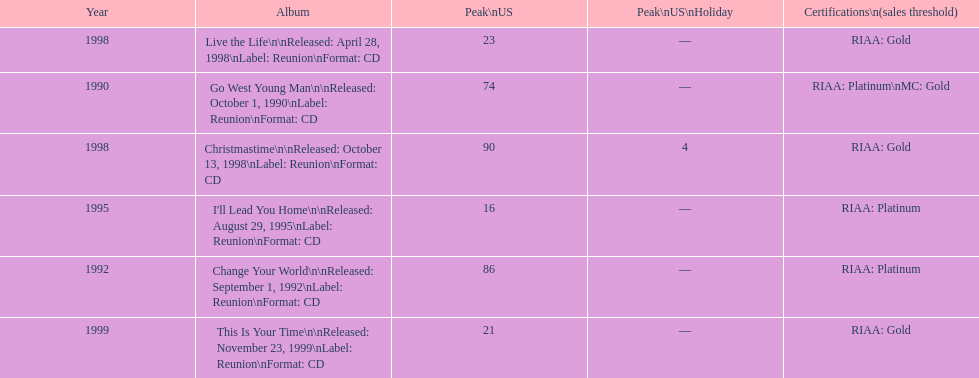How many songs are listed from 1998? 2. 